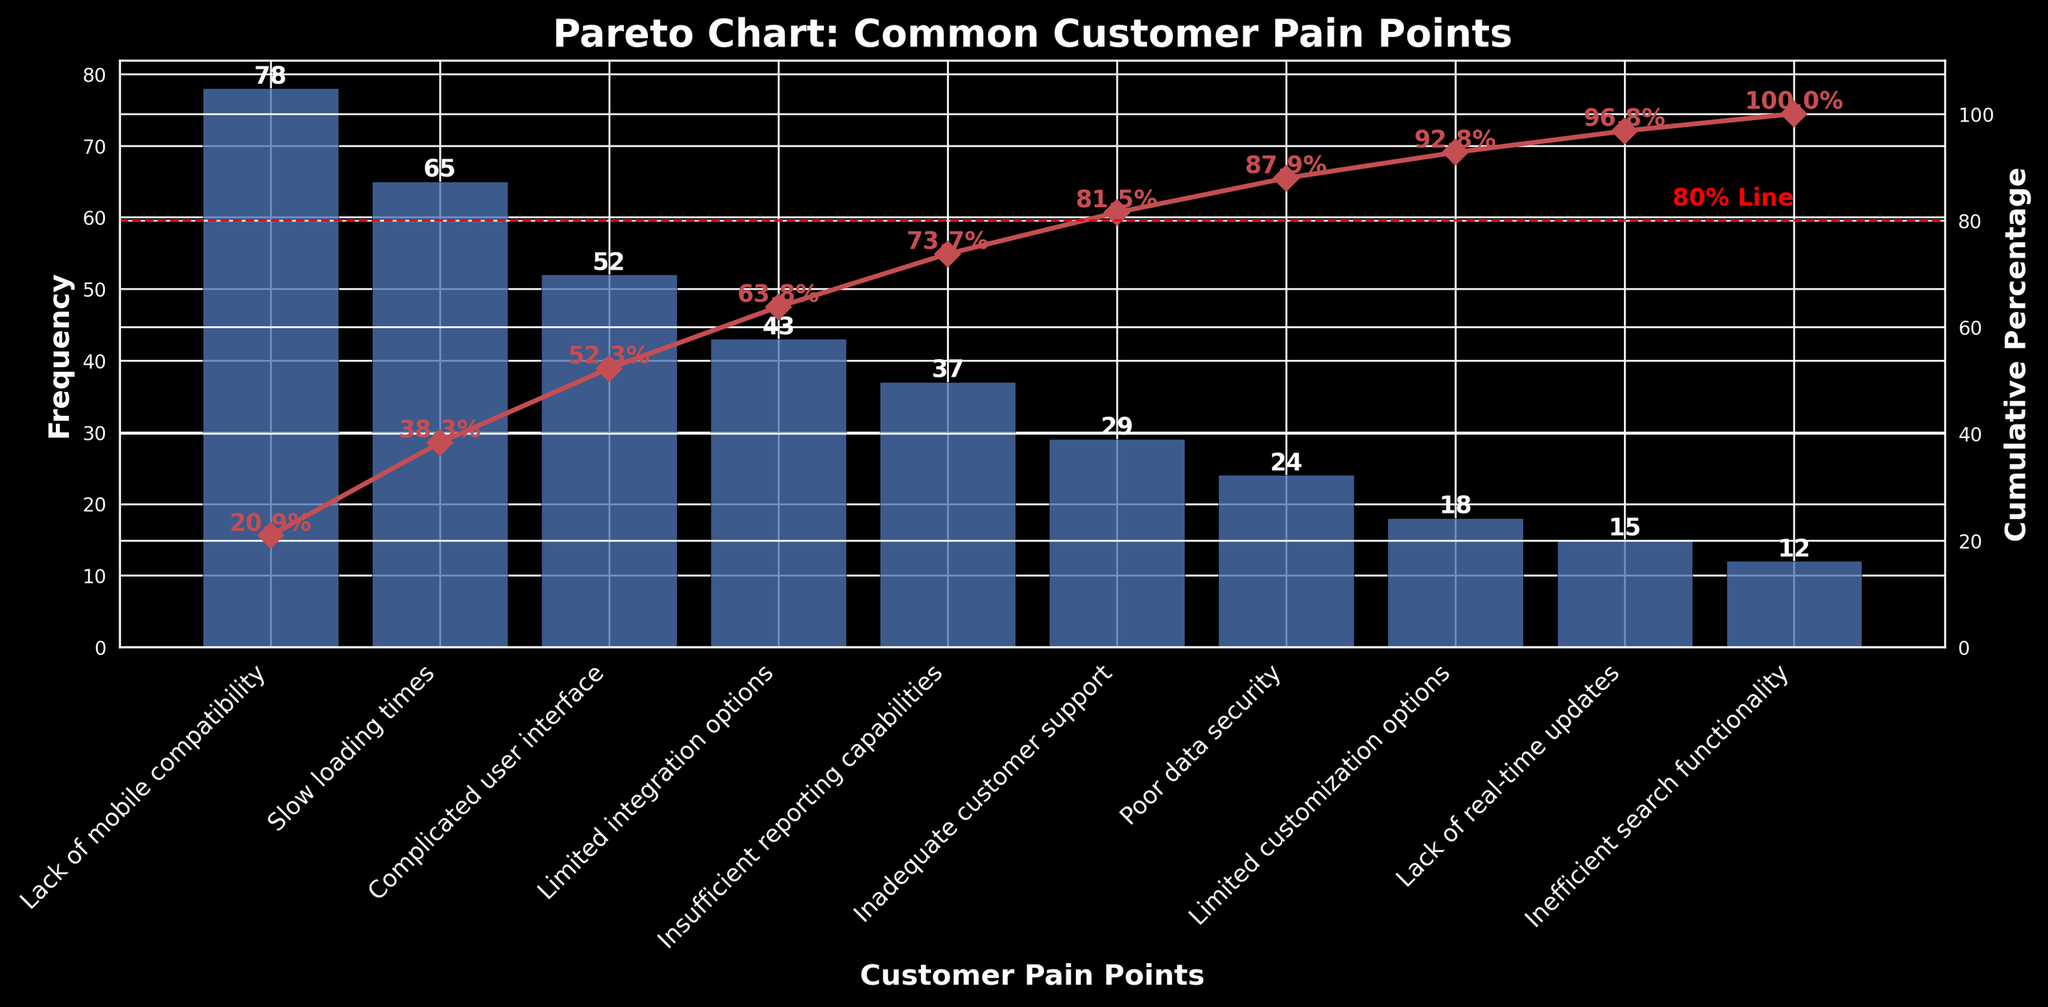What is the title of the figure? The title of the figure is at the top and summarizes the overall topic being visualized. From the visual representation, we can read the title directly.
Answer: Pareto Chart: Common Customer Pain Points Which customer pain point has the highest frequency? The highest bar in the bar chart represents the customer pain point with the highest frequency. We can see that "Lack of mobile compatibility" has the tallest bar.
Answer: Lack of mobile compatibility What is the cumulative percentage at the second data point? On the cumulative percentage line, at the position of the second bar (second data point), there is a marker with a label showing the cumulative percentage. For the second data point, it is at 52.9%.
Answer: 52.9% How many customer pain points are there in total? Counting the number of bars in the bar chart gives us the total number of customer pain points represented.
Answer: 10 What is the frequency of the fourth most common customer pain point? The fourth bar from the left represents the fourth most common customer pain point, which has a height that corresponds to its frequency. By looking at the label on top of the fourth bar, we see it is 43.
Answer: 43 At which percentage does the chart introduce the 80% line? The chart includes a dashed horizontal line labeled "80% Line", and it is positioned at the 80% mark on the cumulative percentage axis.
Answer: 80% How does the cumulative percentage after the top three pain points compare to 80%? Adding the cumulative percentages displayed at and after the top three bars, we see it reaches 75.6%, which is less than the 80% line introduced in the Pareto chart.
Answer: Less than 80% Which pain point is responsible for the cumulative frequency surpassing 80%? The cumulative percentage line crosses the 80% line marker between the fourth and fifth bars, indicating that after addressing the top five pain points, the cumulative frequency surpasses 80%.
Answer: Insufficient reporting capabilities How many pain points need to be addressed to reach over 80% of the cumulative frequency? By looking closely at the cumulative percentage line, we see that it surpasses the 80% threshold after the fifth bar. Thus, addressing the top five pain points suffices.
Answer: 5 What is the combined frequency of the three least common pain points? The three least common pain points are represented by the three shortest bars. The frequencies of these are 18, 15, and 12, respectively. Adding these gives 18 + 15 + 12 = 45.
Answer: 45 